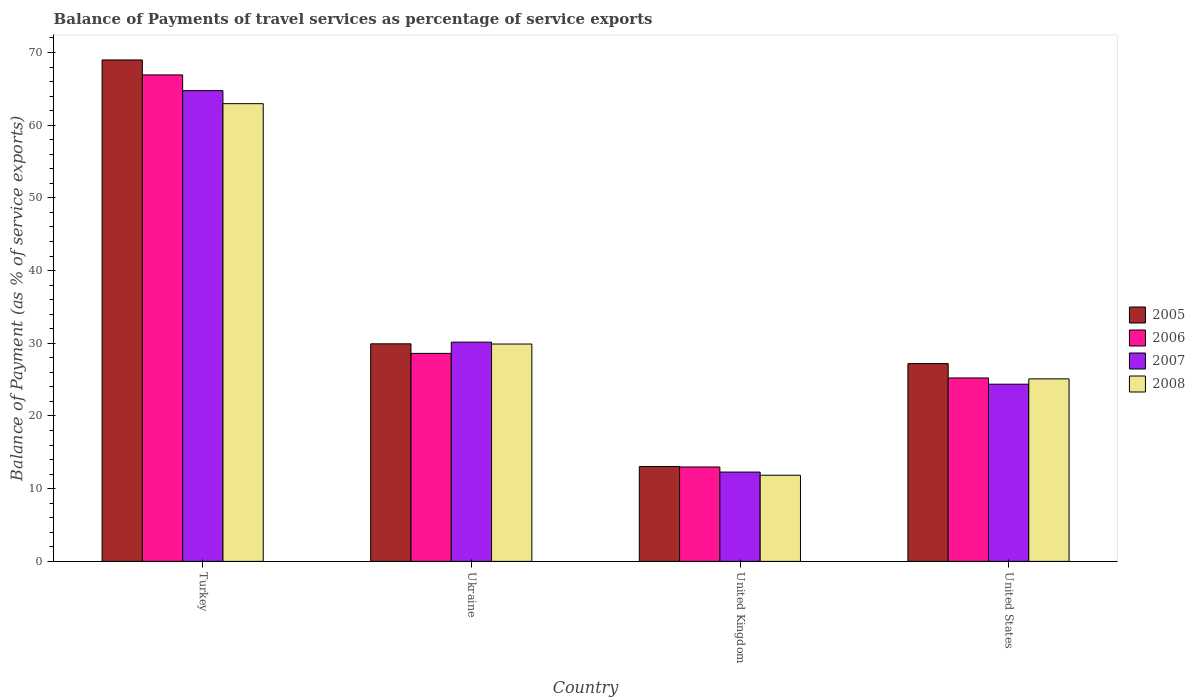How many groups of bars are there?
Offer a terse response. 4. Are the number of bars per tick equal to the number of legend labels?
Keep it short and to the point. Yes. Are the number of bars on each tick of the X-axis equal?
Make the answer very short. Yes. In how many cases, is the number of bars for a given country not equal to the number of legend labels?
Offer a terse response. 0. What is the balance of payments of travel services in 2006 in United Kingdom?
Offer a terse response. 12.98. Across all countries, what is the maximum balance of payments of travel services in 2005?
Provide a succinct answer. 68.98. Across all countries, what is the minimum balance of payments of travel services in 2005?
Provide a short and direct response. 13.05. In which country was the balance of payments of travel services in 2008 maximum?
Make the answer very short. Turkey. What is the total balance of payments of travel services in 2006 in the graph?
Give a very brief answer. 133.74. What is the difference between the balance of payments of travel services in 2006 in Ukraine and that in United States?
Your answer should be compact. 3.38. What is the difference between the balance of payments of travel services in 2006 in Turkey and the balance of payments of travel services in 2008 in Ukraine?
Provide a succinct answer. 37.02. What is the average balance of payments of travel services in 2006 per country?
Provide a short and direct response. 33.44. What is the difference between the balance of payments of travel services of/in 2007 and balance of payments of travel services of/in 2005 in United States?
Offer a very short reply. -2.83. In how many countries, is the balance of payments of travel services in 2007 greater than 70 %?
Give a very brief answer. 0. What is the ratio of the balance of payments of travel services in 2008 in United Kingdom to that in United States?
Offer a terse response. 0.47. What is the difference between the highest and the second highest balance of payments of travel services in 2007?
Your response must be concise. 40.38. What is the difference between the highest and the lowest balance of payments of travel services in 2008?
Your answer should be very brief. 51.11. Is the sum of the balance of payments of travel services in 2007 in United Kingdom and United States greater than the maximum balance of payments of travel services in 2008 across all countries?
Provide a succinct answer. No. Is it the case that in every country, the sum of the balance of payments of travel services in 2005 and balance of payments of travel services in 2006 is greater than the sum of balance of payments of travel services in 2007 and balance of payments of travel services in 2008?
Keep it short and to the point. No. How many bars are there?
Ensure brevity in your answer.  16. What is the difference between two consecutive major ticks on the Y-axis?
Your answer should be compact. 10. Are the values on the major ticks of Y-axis written in scientific E-notation?
Make the answer very short. No. Does the graph contain any zero values?
Your answer should be compact. No. Where does the legend appear in the graph?
Your answer should be compact. Center right. What is the title of the graph?
Provide a short and direct response. Balance of Payments of travel services as percentage of service exports. Does "1972" appear as one of the legend labels in the graph?
Give a very brief answer. No. What is the label or title of the X-axis?
Provide a short and direct response. Country. What is the label or title of the Y-axis?
Offer a very short reply. Balance of Payment (as % of service exports). What is the Balance of Payment (as % of service exports) in 2005 in Turkey?
Offer a very short reply. 68.98. What is the Balance of Payment (as % of service exports) in 2006 in Turkey?
Keep it short and to the point. 66.92. What is the Balance of Payment (as % of service exports) in 2007 in Turkey?
Offer a terse response. 64.76. What is the Balance of Payment (as % of service exports) in 2008 in Turkey?
Give a very brief answer. 62.96. What is the Balance of Payment (as % of service exports) in 2005 in Ukraine?
Provide a succinct answer. 29.93. What is the Balance of Payment (as % of service exports) in 2006 in Ukraine?
Your answer should be compact. 28.61. What is the Balance of Payment (as % of service exports) of 2007 in Ukraine?
Offer a very short reply. 30.16. What is the Balance of Payment (as % of service exports) in 2008 in Ukraine?
Make the answer very short. 29.9. What is the Balance of Payment (as % of service exports) in 2005 in United Kingdom?
Ensure brevity in your answer.  13.05. What is the Balance of Payment (as % of service exports) in 2006 in United Kingdom?
Provide a succinct answer. 12.98. What is the Balance of Payment (as % of service exports) in 2007 in United Kingdom?
Your answer should be compact. 12.28. What is the Balance of Payment (as % of service exports) of 2008 in United Kingdom?
Offer a terse response. 11.85. What is the Balance of Payment (as % of service exports) of 2005 in United States?
Offer a terse response. 27.2. What is the Balance of Payment (as % of service exports) in 2006 in United States?
Give a very brief answer. 25.23. What is the Balance of Payment (as % of service exports) in 2007 in United States?
Your response must be concise. 24.37. What is the Balance of Payment (as % of service exports) of 2008 in United States?
Provide a succinct answer. 25.11. Across all countries, what is the maximum Balance of Payment (as % of service exports) of 2005?
Provide a short and direct response. 68.98. Across all countries, what is the maximum Balance of Payment (as % of service exports) in 2006?
Give a very brief answer. 66.92. Across all countries, what is the maximum Balance of Payment (as % of service exports) in 2007?
Provide a short and direct response. 64.76. Across all countries, what is the maximum Balance of Payment (as % of service exports) in 2008?
Give a very brief answer. 62.96. Across all countries, what is the minimum Balance of Payment (as % of service exports) in 2005?
Provide a short and direct response. 13.05. Across all countries, what is the minimum Balance of Payment (as % of service exports) of 2006?
Provide a short and direct response. 12.98. Across all countries, what is the minimum Balance of Payment (as % of service exports) of 2007?
Ensure brevity in your answer.  12.28. Across all countries, what is the minimum Balance of Payment (as % of service exports) in 2008?
Give a very brief answer. 11.85. What is the total Balance of Payment (as % of service exports) of 2005 in the graph?
Provide a succinct answer. 139.16. What is the total Balance of Payment (as % of service exports) of 2006 in the graph?
Ensure brevity in your answer.  133.74. What is the total Balance of Payment (as % of service exports) of 2007 in the graph?
Give a very brief answer. 131.57. What is the total Balance of Payment (as % of service exports) in 2008 in the graph?
Offer a terse response. 129.81. What is the difference between the Balance of Payment (as % of service exports) of 2005 in Turkey and that in Ukraine?
Give a very brief answer. 39.05. What is the difference between the Balance of Payment (as % of service exports) in 2006 in Turkey and that in Ukraine?
Provide a succinct answer. 38.31. What is the difference between the Balance of Payment (as % of service exports) of 2007 in Turkey and that in Ukraine?
Your answer should be compact. 34.6. What is the difference between the Balance of Payment (as % of service exports) in 2008 in Turkey and that in Ukraine?
Offer a very short reply. 33.06. What is the difference between the Balance of Payment (as % of service exports) in 2005 in Turkey and that in United Kingdom?
Keep it short and to the point. 55.93. What is the difference between the Balance of Payment (as % of service exports) of 2006 in Turkey and that in United Kingdom?
Provide a short and direct response. 53.93. What is the difference between the Balance of Payment (as % of service exports) in 2007 in Turkey and that in United Kingdom?
Your response must be concise. 52.48. What is the difference between the Balance of Payment (as % of service exports) of 2008 in Turkey and that in United Kingdom?
Give a very brief answer. 51.11. What is the difference between the Balance of Payment (as % of service exports) of 2005 in Turkey and that in United States?
Your answer should be compact. 41.77. What is the difference between the Balance of Payment (as % of service exports) of 2006 in Turkey and that in United States?
Make the answer very short. 41.69. What is the difference between the Balance of Payment (as % of service exports) in 2007 in Turkey and that in United States?
Provide a short and direct response. 40.38. What is the difference between the Balance of Payment (as % of service exports) of 2008 in Turkey and that in United States?
Ensure brevity in your answer.  37.86. What is the difference between the Balance of Payment (as % of service exports) in 2005 in Ukraine and that in United Kingdom?
Your response must be concise. 16.88. What is the difference between the Balance of Payment (as % of service exports) in 2006 in Ukraine and that in United Kingdom?
Offer a terse response. 15.63. What is the difference between the Balance of Payment (as % of service exports) in 2007 in Ukraine and that in United Kingdom?
Provide a short and direct response. 17.87. What is the difference between the Balance of Payment (as % of service exports) of 2008 in Ukraine and that in United Kingdom?
Offer a terse response. 18.05. What is the difference between the Balance of Payment (as % of service exports) in 2005 in Ukraine and that in United States?
Keep it short and to the point. 2.72. What is the difference between the Balance of Payment (as % of service exports) of 2006 in Ukraine and that in United States?
Your answer should be very brief. 3.38. What is the difference between the Balance of Payment (as % of service exports) of 2007 in Ukraine and that in United States?
Make the answer very short. 5.78. What is the difference between the Balance of Payment (as % of service exports) of 2008 in Ukraine and that in United States?
Offer a terse response. 4.79. What is the difference between the Balance of Payment (as % of service exports) in 2005 in United Kingdom and that in United States?
Keep it short and to the point. -14.15. What is the difference between the Balance of Payment (as % of service exports) of 2006 in United Kingdom and that in United States?
Provide a short and direct response. -12.24. What is the difference between the Balance of Payment (as % of service exports) of 2007 in United Kingdom and that in United States?
Your answer should be compact. -12.09. What is the difference between the Balance of Payment (as % of service exports) in 2008 in United Kingdom and that in United States?
Give a very brief answer. -13.26. What is the difference between the Balance of Payment (as % of service exports) of 2005 in Turkey and the Balance of Payment (as % of service exports) of 2006 in Ukraine?
Your response must be concise. 40.37. What is the difference between the Balance of Payment (as % of service exports) of 2005 in Turkey and the Balance of Payment (as % of service exports) of 2007 in Ukraine?
Provide a succinct answer. 38.82. What is the difference between the Balance of Payment (as % of service exports) of 2005 in Turkey and the Balance of Payment (as % of service exports) of 2008 in Ukraine?
Your response must be concise. 39.08. What is the difference between the Balance of Payment (as % of service exports) of 2006 in Turkey and the Balance of Payment (as % of service exports) of 2007 in Ukraine?
Keep it short and to the point. 36.76. What is the difference between the Balance of Payment (as % of service exports) in 2006 in Turkey and the Balance of Payment (as % of service exports) in 2008 in Ukraine?
Make the answer very short. 37.02. What is the difference between the Balance of Payment (as % of service exports) in 2007 in Turkey and the Balance of Payment (as % of service exports) in 2008 in Ukraine?
Ensure brevity in your answer.  34.86. What is the difference between the Balance of Payment (as % of service exports) of 2005 in Turkey and the Balance of Payment (as % of service exports) of 2006 in United Kingdom?
Your answer should be very brief. 55.99. What is the difference between the Balance of Payment (as % of service exports) of 2005 in Turkey and the Balance of Payment (as % of service exports) of 2007 in United Kingdom?
Give a very brief answer. 56.7. What is the difference between the Balance of Payment (as % of service exports) of 2005 in Turkey and the Balance of Payment (as % of service exports) of 2008 in United Kingdom?
Make the answer very short. 57.13. What is the difference between the Balance of Payment (as % of service exports) of 2006 in Turkey and the Balance of Payment (as % of service exports) of 2007 in United Kingdom?
Make the answer very short. 54.64. What is the difference between the Balance of Payment (as % of service exports) in 2006 in Turkey and the Balance of Payment (as % of service exports) in 2008 in United Kingdom?
Your answer should be very brief. 55.07. What is the difference between the Balance of Payment (as % of service exports) in 2007 in Turkey and the Balance of Payment (as % of service exports) in 2008 in United Kingdom?
Offer a terse response. 52.91. What is the difference between the Balance of Payment (as % of service exports) of 2005 in Turkey and the Balance of Payment (as % of service exports) of 2006 in United States?
Give a very brief answer. 43.75. What is the difference between the Balance of Payment (as % of service exports) of 2005 in Turkey and the Balance of Payment (as % of service exports) of 2007 in United States?
Your answer should be very brief. 44.6. What is the difference between the Balance of Payment (as % of service exports) in 2005 in Turkey and the Balance of Payment (as % of service exports) in 2008 in United States?
Ensure brevity in your answer.  43.87. What is the difference between the Balance of Payment (as % of service exports) of 2006 in Turkey and the Balance of Payment (as % of service exports) of 2007 in United States?
Provide a short and direct response. 42.55. What is the difference between the Balance of Payment (as % of service exports) in 2006 in Turkey and the Balance of Payment (as % of service exports) in 2008 in United States?
Provide a succinct answer. 41.81. What is the difference between the Balance of Payment (as % of service exports) of 2007 in Turkey and the Balance of Payment (as % of service exports) of 2008 in United States?
Provide a short and direct response. 39.65. What is the difference between the Balance of Payment (as % of service exports) in 2005 in Ukraine and the Balance of Payment (as % of service exports) in 2006 in United Kingdom?
Ensure brevity in your answer.  16.94. What is the difference between the Balance of Payment (as % of service exports) of 2005 in Ukraine and the Balance of Payment (as % of service exports) of 2007 in United Kingdom?
Keep it short and to the point. 17.64. What is the difference between the Balance of Payment (as % of service exports) in 2005 in Ukraine and the Balance of Payment (as % of service exports) in 2008 in United Kingdom?
Offer a very short reply. 18.08. What is the difference between the Balance of Payment (as % of service exports) in 2006 in Ukraine and the Balance of Payment (as % of service exports) in 2007 in United Kingdom?
Offer a very short reply. 16.33. What is the difference between the Balance of Payment (as % of service exports) of 2006 in Ukraine and the Balance of Payment (as % of service exports) of 2008 in United Kingdom?
Offer a very short reply. 16.76. What is the difference between the Balance of Payment (as % of service exports) in 2007 in Ukraine and the Balance of Payment (as % of service exports) in 2008 in United Kingdom?
Provide a short and direct response. 18.31. What is the difference between the Balance of Payment (as % of service exports) in 2005 in Ukraine and the Balance of Payment (as % of service exports) in 2006 in United States?
Keep it short and to the point. 4.7. What is the difference between the Balance of Payment (as % of service exports) of 2005 in Ukraine and the Balance of Payment (as % of service exports) of 2007 in United States?
Your answer should be very brief. 5.55. What is the difference between the Balance of Payment (as % of service exports) of 2005 in Ukraine and the Balance of Payment (as % of service exports) of 2008 in United States?
Your answer should be compact. 4.82. What is the difference between the Balance of Payment (as % of service exports) in 2006 in Ukraine and the Balance of Payment (as % of service exports) in 2007 in United States?
Your answer should be very brief. 4.24. What is the difference between the Balance of Payment (as % of service exports) of 2006 in Ukraine and the Balance of Payment (as % of service exports) of 2008 in United States?
Your answer should be compact. 3.5. What is the difference between the Balance of Payment (as % of service exports) in 2007 in Ukraine and the Balance of Payment (as % of service exports) in 2008 in United States?
Offer a very short reply. 5.05. What is the difference between the Balance of Payment (as % of service exports) of 2005 in United Kingdom and the Balance of Payment (as % of service exports) of 2006 in United States?
Make the answer very short. -12.18. What is the difference between the Balance of Payment (as % of service exports) of 2005 in United Kingdom and the Balance of Payment (as % of service exports) of 2007 in United States?
Give a very brief answer. -11.32. What is the difference between the Balance of Payment (as % of service exports) in 2005 in United Kingdom and the Balance of Payment (as % of service exports) in 2008 in United States?
Keep it short and to the point. -12.05. What is the difference between the Balance of Payment (as % of service exports) in 2006 in United Kingdom and the Balance of Payment (as % of service exports) in 2007 in United States?
Your answer should be compact. -11.39. What is the difference between the Balance of Payment (as % of service exports) of 2006 in United Kingdom and the Balance of Payment (as % of service exports) of 2008 in United States?
Offer a very short reply. -12.12. What is the difference between the Balance of Payment (as % of service exports) in 2007 in United Kingdom and the Balance of Payment (as % of service exports) in 2008 in United States?
Your answer should be very brief. -12.82. What is the average Balance of Payment (as % of service exports) in 2005 per country?
Your answer should be compact. 34.79. What is the average Balance of Payment (as % of service exports) of 2006 per country?
Provide a succinct answer. 33.44. What is the average Balance of Payment (as % of service exports) in 2007 per country?
Ensure brevity in your answer.  32.89. What is the average Balance of Payment (as % of service exports) in 2008 per country?
Ensure brevity in your answer.  32.45. What is the difference between the Balance of Payment (as % of service exports) of 2005 and Balance of Payment (as % of service exports) of 2006 in Turkey?
Offer a terse response. 2.06. What is the difference between the Balance of Payment (as % of service exports) of 2005 and Balance of Payment (as % of service exports) of 2007 in Turkey?
Provide a short and direct response. 4.22. What is the difference between the Balance of Payment (as % of service exports) in 2005 and Balance of Payment (as % of service exports) in 2008 in Turkey?
Give a very brief answer. 6.01. What is the difference between the Balance of Payment (as % of service exports) in 2006 and Balance of Payment (as % of service exports) in 2007 in Turkey?
Offer a terse response. 2.16. What is the difference between the Balance of Payment (as % of service exports) in 2006 and Balance of Payment (as % of service exports) in 2008 in Turkey?
Keep it short and to the point. 3.96. What is the difference between the Balance of Payment (as % of service exports) in 2007 and Balance of Payment (as % of service exports) in 2008 in Turkey?
Your response must be concise. 1.79. What is the difference between the Balance of Payment (as % of service exports) in 2005 and Balance of Payment (as % of service exports) in 2006 in Ukraine?
Your answer should be compact. 1.32. What is the difference between the Balance of Payment (as % of service exports) of 2005 and Balance of Payment (as % of service exports) of 2007 in Ukraine?
Keep it short and to the point. -0.23. What is the difference between the Balance of Payment (as % of service exports) of 2005 and Balance of Payment (as % of service exports) of 2008 in Ukraine?
Offer a terse response. 0.03. What is the difference between the Balance of Payment (as % of service exports) of 2006 and Balance of Payment (as % of service exports) of 2007 in Ukraine?
Your answer should be compact. -1.55. What is the difference between the Balance of Payment (as % of service exports) of 2006 and Balance of Payment (as % of service exports) of 2008 in Ukraine?
Provide a short and direct response. -1.29. What is the difference between the Balance of Payment (as % of service exports) of 2007 and Balance of Payment (as % of service exports) of 2008 in Ukraine?
Provide a succinct answer. 0.26. What is the difference between the Balance of Payment (as % of service exports) in 2005 and Balance of Payment (as % of service exports) in 2006 in United Kingdom?
Your answer should be very brief. 0.07. What is the difference between the Balance of Payment (as % of service exports) in 2005 and Balance of Payment (as % of service exports) in 2007 in United Kingdom?
Offer a very short reply. 0.77. What is the difference between the Balance of Payment (as % of service exports) in 2005 and Balance of Payment (as % of service exports) in 2008 in United Kingdom?
Offer a terse response. 1.2. What is the difference between the Balance of Payment (as % of service exports) in 2006 and Balance of Payment (as % of service exports) in 2007 in United Kingdom?
Ensure brevity in your answer.  0.7. What is the difference between the Balance of Payment (as % of service exports) of 2006 and Balance of Payment (as % of service exports) of 2008 in United Kingdom?
Your answer should be very brief. 1.14. What is the difference between the Balance of Payment (as % of service exports) in 2007 and Balance of Payment (as % of service exports) in 2008 in United Kingdom?
Offer a very short reply. 0.43. What is the difference between the Balance of Payment (as % of service exports) in 2005 and Balance of Payment (as % of service exports) in 2006 in United States?
Your answer should be compact. 1.97. What is the difference between the Balance of Payment (as % of service exports) of 2005 and Balance of Payment (as % of service exports) of 2007 in United States?
Offer a very short reply. 2.83. What is the difference between the Balance of Payment (as % of service exports) of 2005 and Balance of Payment (as % of service exports) of 2008 in United States?
Make the answer very short. 2.1. What is the difference between the Balance of Payment (as % of service exports) of 2006 and Balance of Payment (as % of service exports) of 2007 in United States?
Your answer should be very brief. 0.86. What is the difference between the Balance of Payment (as % of service exports) in 2006 and Balance of Payment (as % of service exports) in 2008 in United States?
Ensure brevity in your answer.  0.12. What is the difference between the Balance of Payment (as % of service exports) of 2007 and Balance of Payment (as % of service exports) of 2008 in United States?
Offer a very short reply. -0.73. What is the ratio of the Balance of Payment (as % of service exports) in 2005 in Turkey to that in Ukraine?
Make the answer very short. 2.3. What is the ratio of the Balance of Payment (as % of service exports) in 2006 in Turkey to that in Ukraine?
Provide a succinct answer. 2.34. What is the ratio of the Balance of Payment (as % of service exports) in 2007 in Turkey to that in Ukraine?
Your answer should be very brief. 2.15. What is the ratio of the Balance of Payment (as % of service exports) in 2008 in Turkey to that in Ukraine?
Offer a terse response. 2.11. What is the ratio of the Balance of Payment (as % of service exports) in 2005 in Turkey to that in United Kingdom?
Provide a short and direct response. 5.29. What is the ratio of the Balance of Payment (as % of service exports) in 2006 in Turkey to that in United Kingdom?
Your answer should be very brief. 5.15. What is the ratio of the Balance of Payment (as % of service exports) of 2007 in Turkey to that in United Kingdom?
Your answer should be compact. 5.27. What is the ratio of the Balance of Payment (as % of service exports) in 2008 in Turkey to that in United Kingdom?
Ensure brevity in your answer.  5.31. What is the ratio of the Balance of Payment (as % of service exports) of 2005 in Turkey to that in United States?
Make the answer very short. 2.54. What is the ratio of the Balance of Payment (as % of service exports) of 2006 in Turkey to that in United States?
Offer a very short reply. 2.65. What is the ratio of the Balance of Payment (as % of service exports) in 2007 in Turkey to that in United States?
Offer a terse response. 2.66. What is the ratio of the Balance of Payment (as % of service exports) of 2008 in Turkey to that in United States?
Your answer should be compact. 2.51. What is the ratio of the Balance of Payment (as % of service exports) of 2005 in Ukraine to that in United Kingdom?
Offer a terse response. 2.29. What is the ratio of the Balance of Payment (as % of service exports) of 2006 in Ukraine to that in United Kingdom?
Your response must be concise. 2.2. What is the ratio of the Balance of Payment (as % of service exports) in 2007 in Ukraine to that in United Kingdom?
Provide a succinct answer. 2.46. What is the ratio of the Balance of Payment (as % of service exports) in 2008 in Ukraine to that in United Kingdom?
Provide a short and direct response. 2.52. What is the ratio of the Balance of Payment (as % of service exports) in 2005 in Ukraine to that in United States?
Offer a terse response. 1.1. What is the ratio of the Balance of Payment (as % of service exports) in 2006 in Ukraine to that in United States?
Provide a short and direct response. 1.13. What is the ratio of the Balance of Payment (as % of service exports) in 2007 in Ukraine to that in United States?
Offer a very short reply. 1.24. What is the ratio of the Balance of Payment (as % of service exports) in 2008 in Ukraine to that in United States?
Your response must be concise. 1.19. What is the ratio of the Balance of Payment (as % of service exports) of 2005 in United Kingdom to that in United States?
Give a very brief answer. 0.48. What is the ratio of the Balance of Payment (as % of service exports) of 2006 in United Kingdom to that in United States?
Your response must be concise. 0.51. What is the ratio of the Balance of Payment (as % of service exports) in 2007 in United Kingdom to that in United States?
Provide a succinct answer. 0.5. What is the ratio of the Balance of Payment (as % of service exports) of 2008 in United Kingdom to that in United States?
Your response must be concise. 0.47. What is the difference between the highest and the second highest Balance of Payment (as % of service exports) in 2005?
Provide a short and direct response. 39.05. What is the difference between the highest and the second highest Balance of Payment (as % of service exports) in 2006?
Ensure brevity in your answer.  38.31. What is the difference between the highest and the second highest Balance of Payment (as % of service exports) of 2007?
Provide a short and direct response. 34.6. What is the difference between the highest and the second highest Balance of Payment (as % of service exports) in 2008?
Your answer should be compact. 33.06. What is the difference between the highest and the lowest Balance of Payment (as % of service exports) in 2005?
Make the answer very short. 55.93. What is the difference between the highest and the lowest Balance of Payment (as % of service exports) of 2006?
Your answer should be compact. 53.93. What is the difference between the highest and the lowest Balance of Payment (as % of service exports) in 2007?
Provide a short and direct response. 52.48. What is the difference between the highest and the lowest Balance of Payment (as % of service exports) of 2008?
Keep it short and to the point. 51.11. 